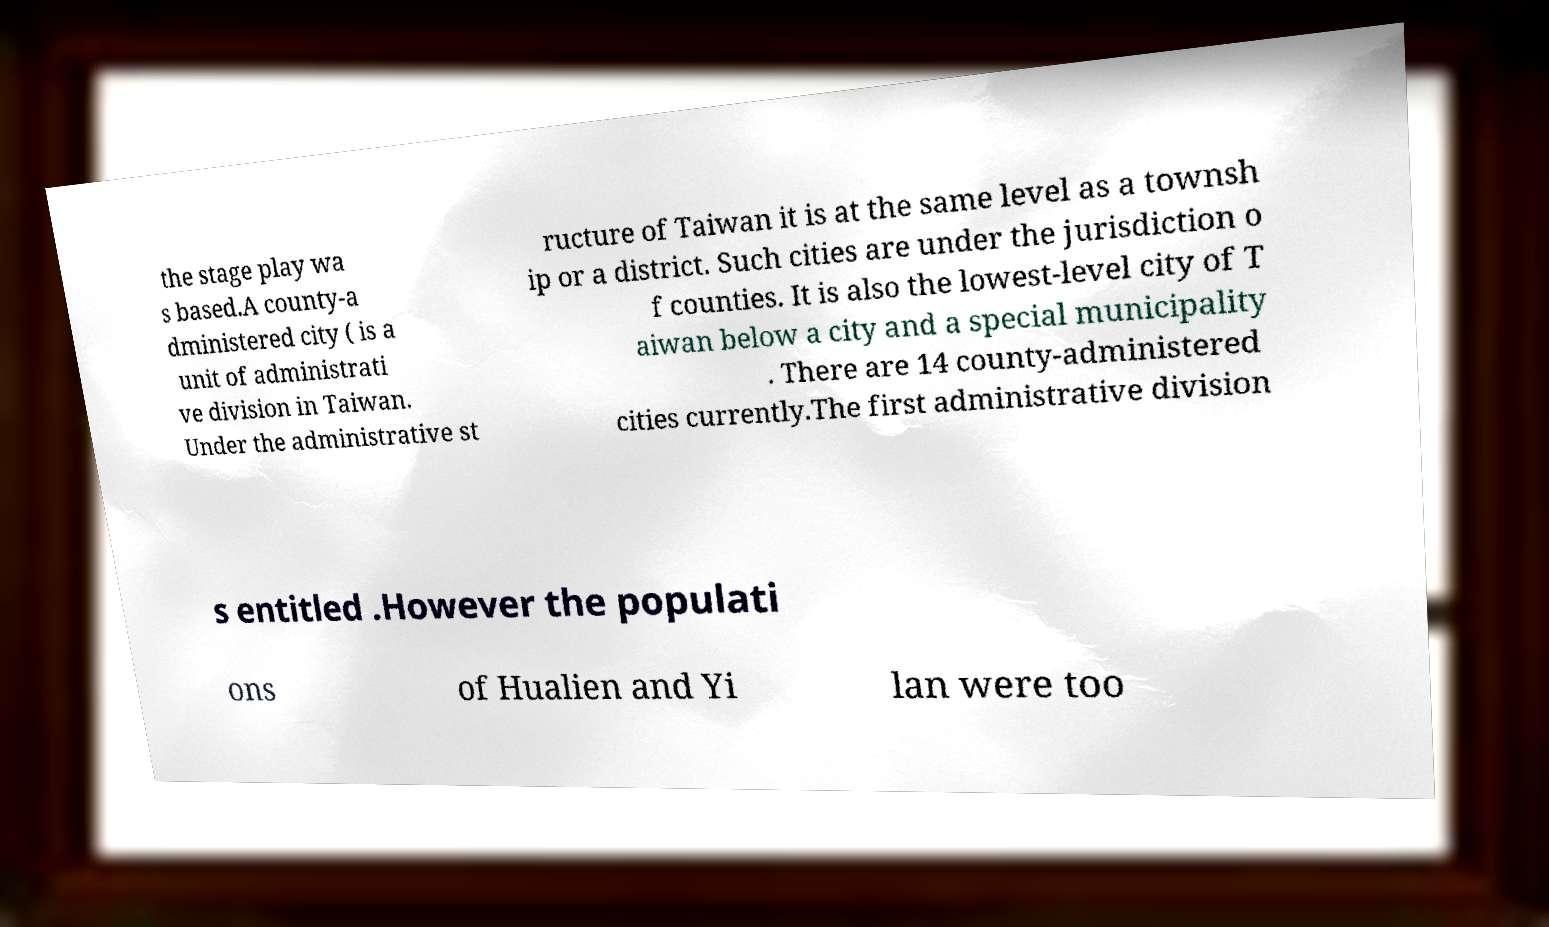Could you extract and type out the text from this image? the stage play wa s based.A county-a dministered city ( is a unit of administrati ve division in Taiwan. Under the administrative st ructure of Taiwan it is at the same level as a townsh ip or a district. Such cities are under the jurisdiction o f counties. It is also the lowest-level city of T aiwan below a city and a special municipality . There are 14 county-administered cities currently.The first administrative division s entitled .However the populati ons of Hualien and Yi lan were too 